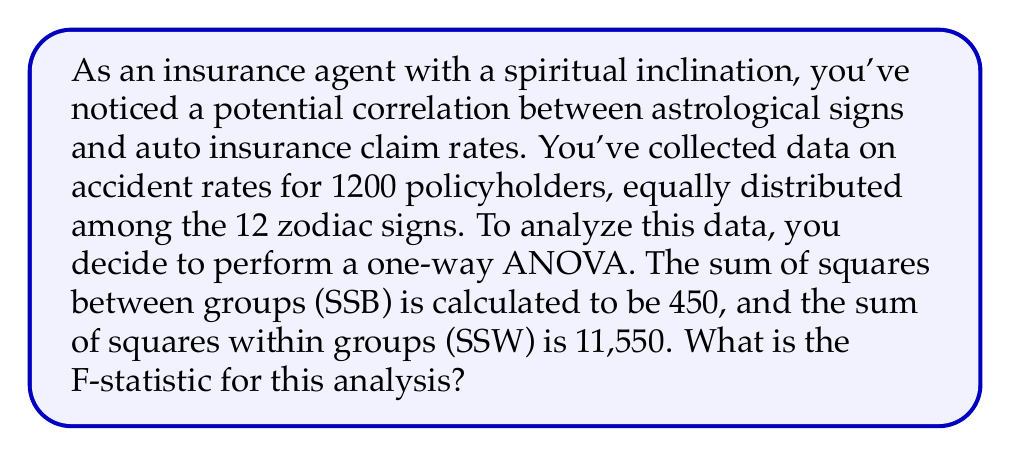Teach me how to tackle this problem. To find the F-statistic, we need to follow these steps:

1) First, let's identify the components of our ANOVA:
   - Number of groups (zodiac signs) = 12
   - Total number of observations = 1200
   - SSB (Sum of Squares Between groups) = 450
   - SSW (Sum of Squares Within groups) = 11,550

2) Calculate the degrees of freedom:
   - df_between = number of groups - 1 = 12 - 1 = 11
   - df_within = total observations - number of groups = 1200 - 12 = 1188

3) Calculate Mean Square Between (MSB):
   $$MSB = \frac{SSB}{df_{between}} = \frac{450}{11} = 40.91$$

4) Calculate Mean Square Within (MSW):
   $$MSW = \frac{SSW}{df_{within}} = \frac{11,550}{1188} = 9.72$$

5) Calculate the F-statistic:
   $$F = \frac{MSB}{MSW} = \frac{40.91}{9.72} = 4.21$$

The F-statistic is the ratio of the variance between groups to the variance within groups. A larger F-value suggests that there is more difference between groups than within groups, which could indicate a significant relationship between astrological signs and accident rates.
Answer: The F-statistic for this analysis is 4.21. 